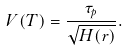Convert formula to latex. <formula><loc_0><loc_0><loc_500><loc_500>V ( T ) = \frac { \tau _ { p } } { \sqrt { H ( r ) } } .</formula> 